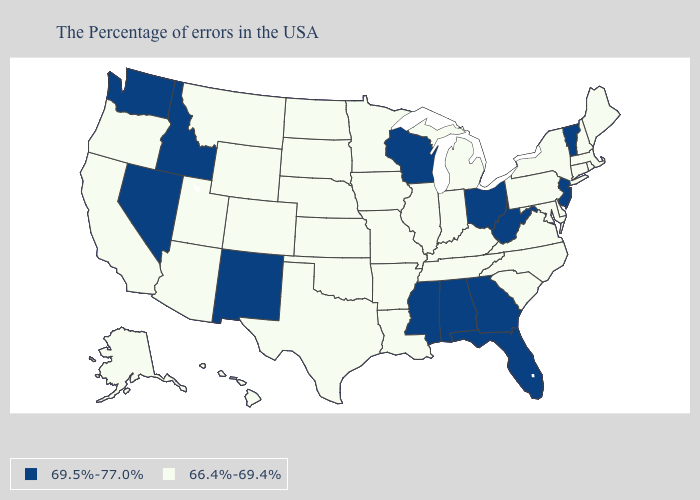Name the states that have a value in the range 66.4%-69.4%?
Short answer required. Maine, Massachusetts, Rhode Island, New Hampshire, Connecticut, New York, Delaware, Maryland, Pennsylvania, Virginia, North Carolina, South Carolina, Michigan, Kentucky, Indiana, Tennessee, Illinois, Louisiana, Missouri, Arkansas, Minnesota, Iowa, Kansas, Nebraska, Oklahoma, Texas, South Dakota, North Dakota, Wyoming, Colorado, Utah, Montana, Arizona, California, Oregon, Alaska, Hawaii. What is the lowest value in the MidWest?
Write a very short answer. 66.4%-69.4%. What is the value of Arkansas?
Short answer required. 66.4%-69.4%. What is the value of Nevada?
Quick response, please. 69.5%-77.0%. Name the states that have a value in the range 69.5%-77.0%?
Short answer required. Vermont, New Jersey, West Virginia, Ohio, Florida, Georgia, Alabama, Wisconsin, Mississippi, New Mexico, Idaho, Nevada, Washington. Is the legend a continuous bar?
Quick response, please. No. What is the value of Vermont?
Short answer required. 69.5%-77.0%. Name the states that have a value in the range 69.5%-77.0%?
Keep it brief. Vermont, New Jersey, West Virginia, Ohio, Florida, Georgia, Alabama, Wisconsin, Mississippi, New Mexico, Idaho, Nevada, Washington. What is the value of Rhode Island?
Keep it brief. 66.4%-69.4%. Does Missouri have the lowest value in the USA?
Short answer required. Yes. What is the highest value in the USA?
Be succinct. 69.5%-77.0%. What is the value of Louisiana?
Concise answer only. 66.4%-69.4%. Which states have the highest value in the USA?
Short answer required. Vermont, New Jersey, West Virginia, Ohio, Florida, Georgia, Alabama, Wisconsin, Mississippi, New Mexico, Idaho, Nevada, Washington. What is the value of Ohio?
Write a very short answer. 69.5%-77.0%. 